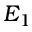Convert formula to latex. <formula><loc_0><loc_0><loc_500><loc_500>E _ { 1 }</formula> 